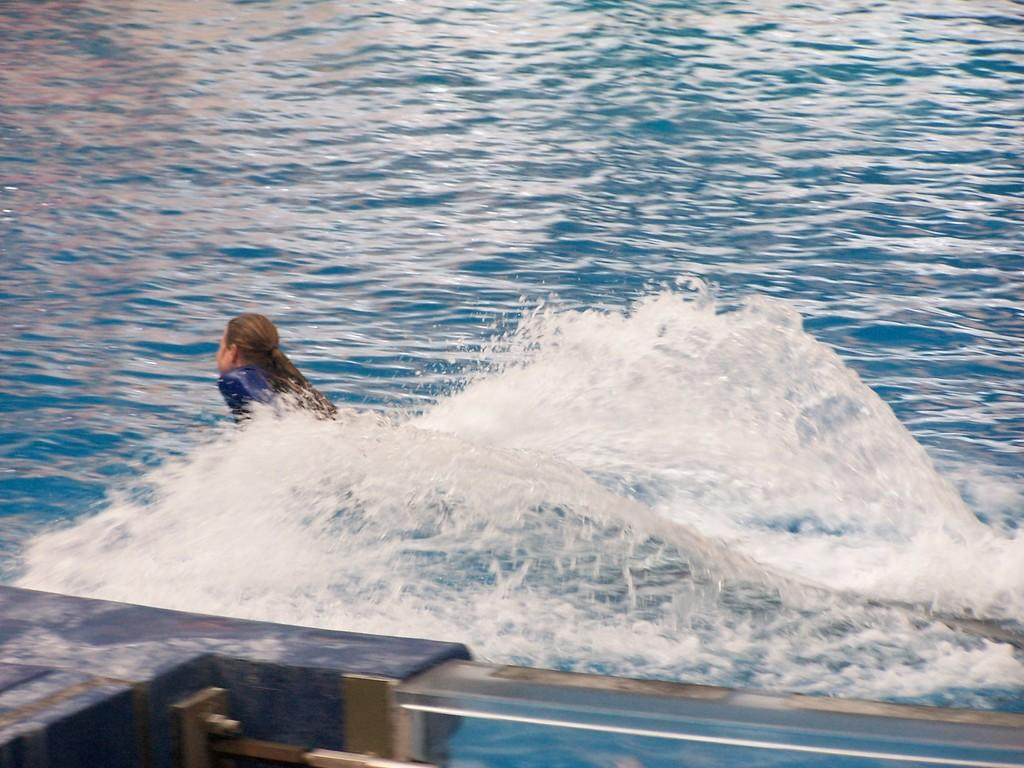What can be seen in the image that might be used for support or safety? There is a railing in the image that could be used for support or safety. What activity is the person in the image engaged in? The person in the image is swimming in the water. What type of bit is the giraffe using to communicate with the person in the image? There is no giraffe present in the image, and therefore no bit or communication between a giraffe and a person can be observed. 